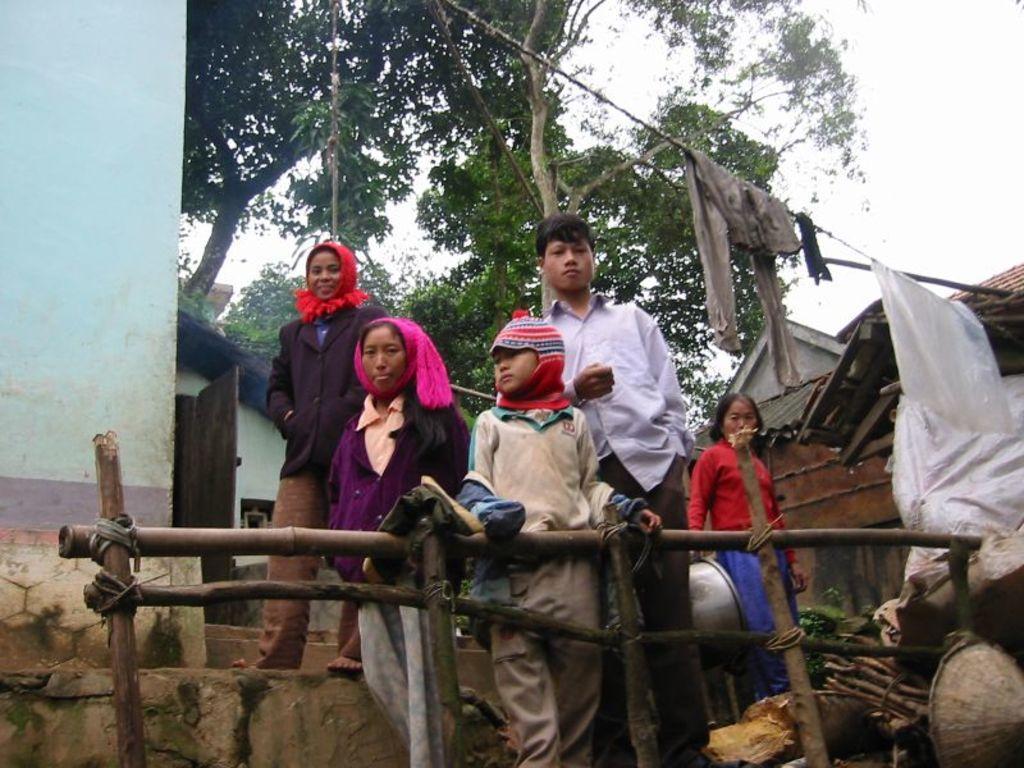How would you summarize this image in a sentence or two? In the background we can see the sky and trees. In this picture we can see houses, rooftops, clothes, door, wooden railing, rope and few objects. We can see people standing. 